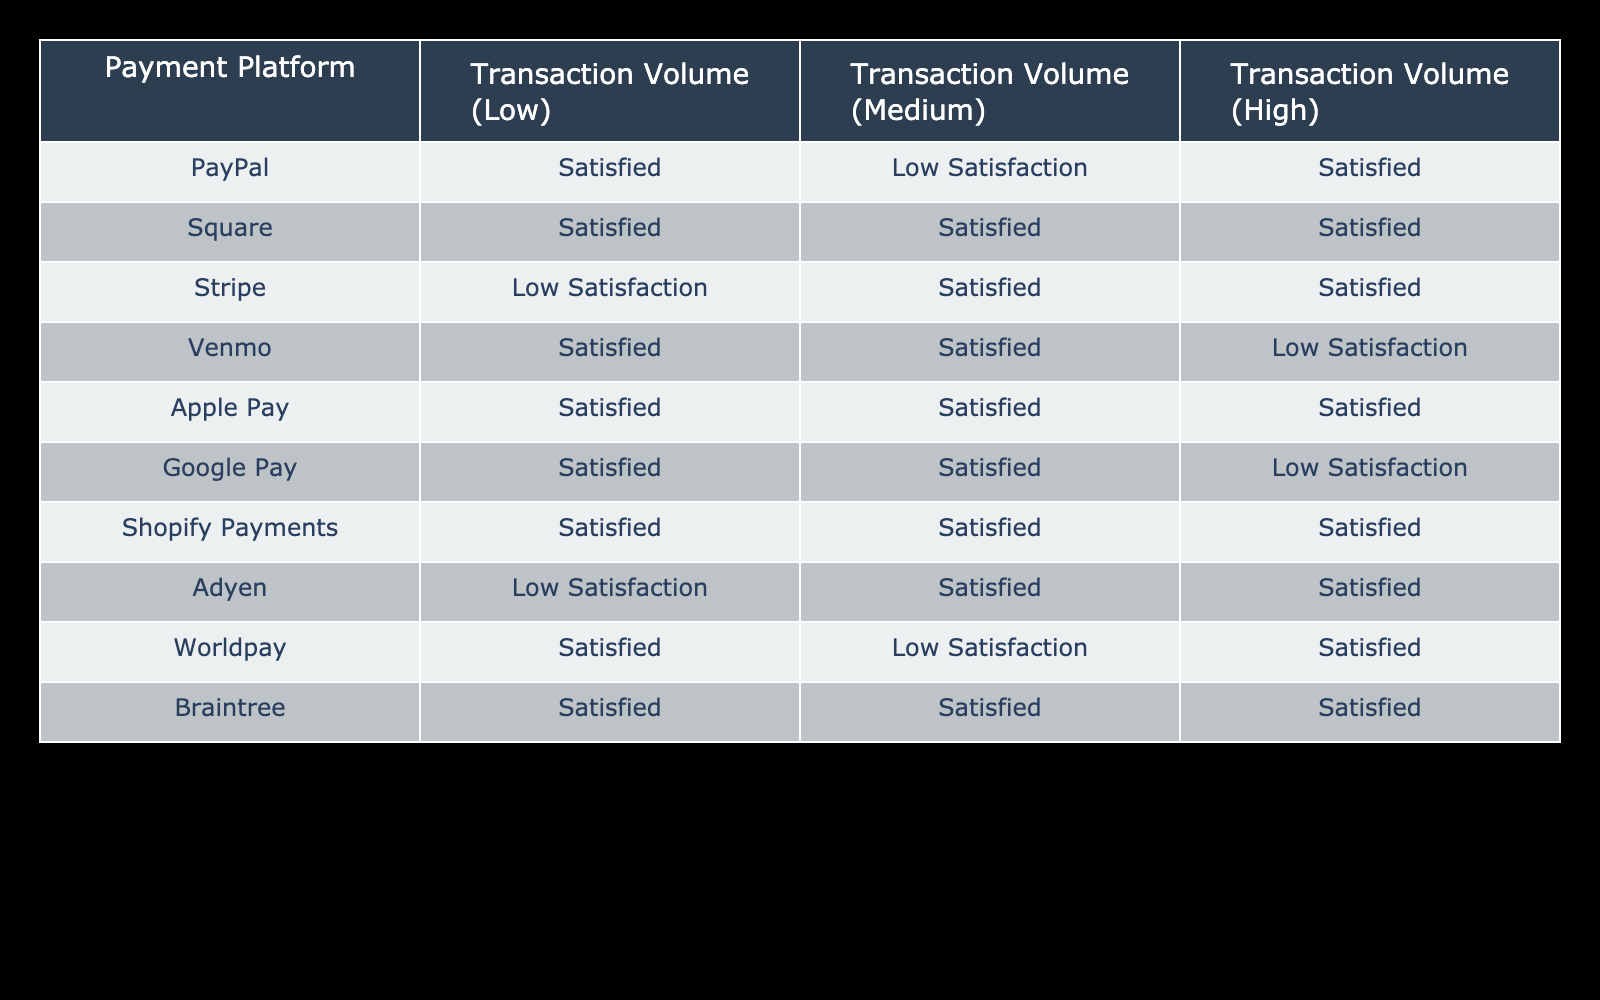What is the satisfaction level for PayPal at high transaction volumes? In the table, I look at the row for PayPal, specifically under the column for high transaction volume. It shows "Satisfied", which indicates that PayPal has a satisfactory level of service for this transaction volume category.
Answer: Satisfied Which payment platform has the lowest satisfaction at medium transaction volumes? To find the platform with the lowest satisfaction at medium transaction volumes, I scan the medium column. The lowest satisfaction level listed is "Low Satisfaction," which corresponds to Stripe and Worldpay. Therefore, both can be considered as having the lowest satisfaction in this category.
Answer: Stripe, Worldpay How many payment platforms have 'Satisfied' ratings across all transaction volumes? I examine each row to check the satisfaction levels for all transaction volumes (low, medium, high). The platforms that consistently show "Satisfied" in all three categories are Square, Apple Pay, and Braintree—totals three platforms.
Answer: 3 Is there any payment platform that has 'Low Satisfaction' at low transaction volumes? I check the low transaction volume column across all platforms. The only platform that shows "Low Satisfaction" in this column is Stripe and Adyen. Therefore, there are platforms with low satisfaction at low transaction volumes.
Answer: Yes What is the average satisfaction level at high transaction volumes for platforms categorized under 'Low Satisfaction'? I review the high transaction volume column and identify the platforms with "Low Satisfaction," which are Venmo, Google Pay, and Stripe. However, since there are only three cases and no numerical values assigned, I interpret low satisfaction as meaning an absence of positive ratings, leading to a 0 average satisfaction. Therefore, the average is calculated across available ratings which isn't possible here, resulting in an interpretation of low satisfaction only.
Answer: Low Satisfaction How many platforms are 'Satisfied' for both low and medium transaction volumes? I go through the table for both the low and medium transaction volume columns. I count how many platforms, when checked against the two columns, show "Satisfied" in both. These platforms are PayPal, Square, Venmo, Apple Pay, Google Pay, Shopify Payments, and Braintree, totaling seven platforms that fit this criterion.
Answer: 7 Which transaction volume category had the most 'Low Satisfaction' ratings across all platforms? I analyze each transaction volume column: Typically, low volume features low satisfaction from Stripe and Adyen. For medium, it's Stripe and Worldpay. And at high volumes, only Venmo shows low satisfaction. From this analysis, low transaction volumes show two instances of low satisfaction. In contrast, medium transaction volumes show two instances as well, and high volume only shows one instance. Thus, the low and medium volumes are tied but they contain the same number of low satisfaction ratings.
Answer: Low and Medium (tied) How does the satisfaction level of Google Pay compare to that of Venmo at medium transaction volumes? I compare the medium transaction volume satisfaction levels for both Google Pay and Venmo directly from the table. Google Pay shows "Satisfied," while Venmo shows "Satisfied," thus the satisfaction levels are the same in this comparison for medium transaction volumes.
Answer: Same 